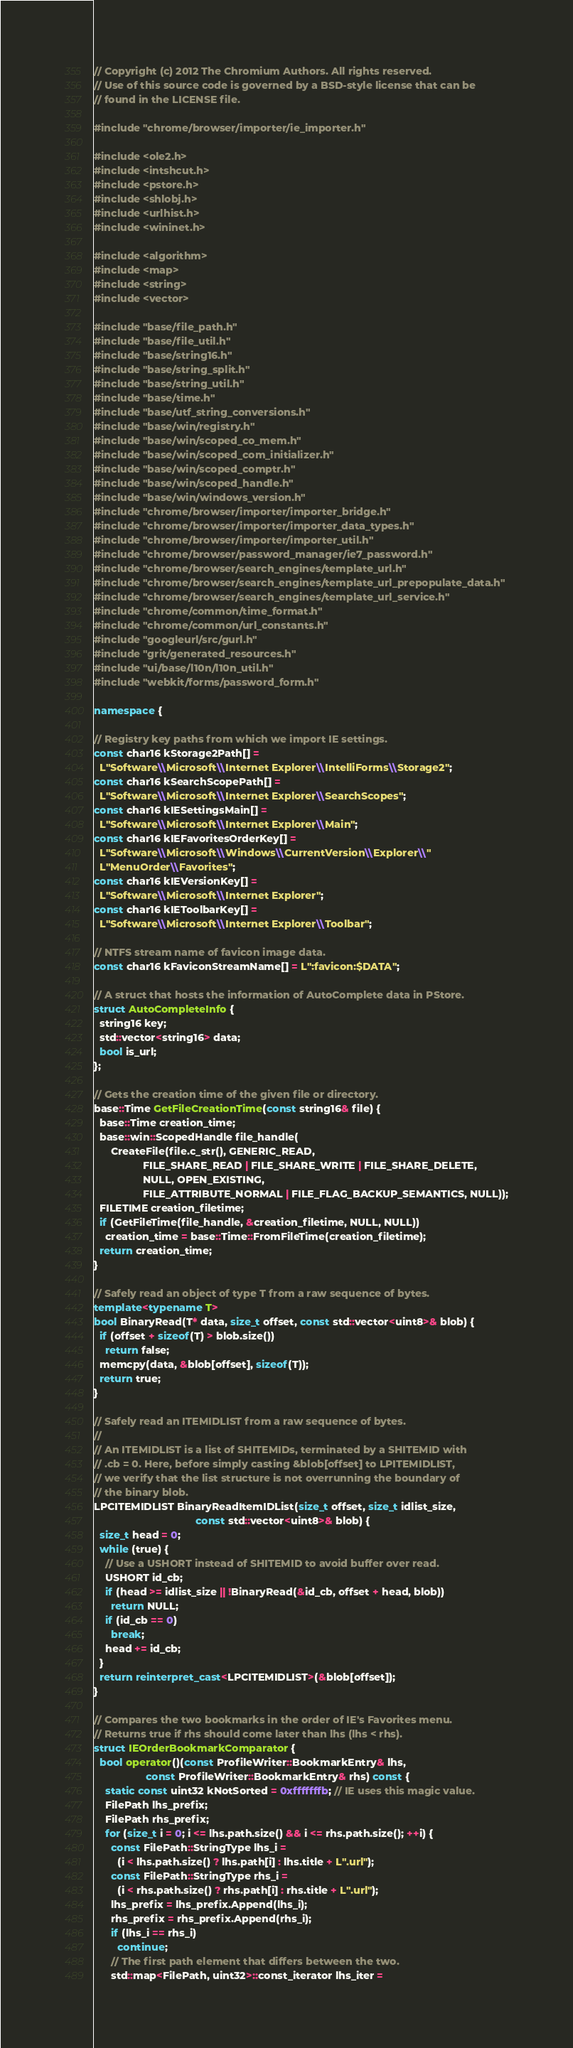Convert code to text. <code><loc_0><loc_0><loc_500><loc_500><_C++_>// Copyright (c) 2012 The Chromium Authors. All rights reserved.
// Use of this source code is governed by a BSD-style license that can be
// found in the LICENSE file.

#include "chrome/browser/importer/ie_importer.h"

#include <ole2.h>
#include <intshcut.h>
#include <pstore.h>
#include <shlobj.h>
#include <urlhist.h>
#include <wininet.h>

#include <algorithm>
#include <map>
#include <string>
#include <vector>

#include "base/file_path.h"
#include "base/file_util.h"
#include "base/string16.h"
#include "base/string_split.h"
#include "base/string_util.h"
#include "base/time.h"
#include "base/utf_string_conversions.h"
#include "base/win/registry.h"
#include "base/win/scoped_co_mem.h"
#include "base/win/scoped_com_initializer.h"
#include "base/win/scoped_comptr.h"
#include "base/win/scoped_handle.h"
#include "base/win/windows_version.h"
#include "chrome/browser/importer/importer_bridge.h"
#include "chrome/browser/importer/importer_data_types.h"
#include "chrome/browser/importer/importer_util.h"
#include "chrome/browser/password_manager/ie7_password.h"
#include "chrome/browser/search_engines/template_url.h"
#include "chrome/browser/search_engines/template_url_prepopulate_data.h"
#include "chrome/browser/search_engines/template_url_service.h"
#include "chrome/common/time_format.h"
#include "chrome/common/url_constants.h"
#include "googleurl/src/gurl.h"
#include "grit/generated_resources.h"
#include "ui/base/l10n/l10n_util.h"
#include "webkit/forms/password_form.h"

namespace {

// Registry key paths from which we import IE settings.
const char16 kStorage2Path[] =
  L"Software\\Microsoft\\Internet Explorer\\IntelliForms\\Storage2";
const char16 kSearchScopePath[] =
  L"Software\\Microsoft\\Internet Explorer\\SearchScopes";
const char16 kIESettingsMain[] =
  L"Software\\Microsoft\\Internet Explorer\\Main";
const char16 kIEFavoritesOrderKey[] =
  L"Software\\Microsoft\\Windows\\CurrentVersion\\Explorer\\"
  L"MenuOrder\\Favorites";
const char16 kIEVersionKey[] =
  L"Software\\Microsoft\\Internet Explorer";
const char16 kIEToolbarKey[] =
  L"Software\\Microsoft\\Internet Explorer\\Toolbar";

// NTFS stream name of favicon image data.
const char16 kFaviconStreamName[] = L":favicon:$DATA";

// A struct that hosts the information of AutoComplete data in PStore.
struct AutoCompleteInfo {
  string16 key;
  std::vector<string16> data;
  bool is_url;
};

// Gets the creation time of the given file or directory.
base::Time GetFileCreationTime(const string16& file) {
  base::Time creation_time;
  base::win::ScopedHandle file_handle(
      CreateFile(file.c_str(), GENERIC_READ,
                 FILE_SHARE_READ | FILE_SHARE_WRITE | FILE_SHARE_DELETE,
                 NULL, OPEN_EXISTING,
                 FILE_ATTRIBUTE_NORMAL | FILE_FLAG_BACKUP_SEMANTICS, NULL));
  FILETIME creation_filetime;
  if (GetFileTime(file_handle, &creation_filetime, NULL, NULL))
    creation_time = base::Time::FromFileTime(creation_filetime);
  return creation_time;
}

// Safely read an object of type T from a raw sequence of bytes.
template<typename T>
bool BinaryRead(T* data, size_t offset, const std::vector<uint8>& blob) {
  if (offset + sizeof(T) > blob.size())
    return false;
  memcpy(data, &blob[offset], sizeof(T));
  return true;
}

// Safely read an ITEMIDLIST from a raw sequence of bytes.
//
// An ITEMIDLIST is a list of SHITEMIDs, terminated by a SHITEMID with
// .cb = 0. Here, before simply casting &blob[offset] to LPITEMIDLIST,
// we verify that the list structure is not overrunning the boundary of
// the binary blob.
LPCITEMIDLIST BinaryReadItemIDList(size_t offset, size_t idlist_size,
                                   const std::vector<uint8>& blob) {
  size_t head = 0;
  while (true) {
    // Use a USHORT instead of SHITEMID to avoid buffer over read.
    USHORT id_cb;
    if (head >= idlist_size || !BinaryRead(&id_cb, offset + head, blob))
      return NULL;
    if (id_cb == 0)
      break;
    head += id_cb;
  }
  return reinterpret_cast<LPCITEMIDLIST>(&blob[offset]);
}

// Compares the two bookmarks in the order of IE's Favorites menu.
// Returns true if rhs should come later than lhs (lhs < rhs).
struct IEOrderBookmarkComparator {
  bool operator()(const ProfileWriter::BookmarkEntry& lhs,
                  const ProfileWriter::BookmarkEntry& rhs) const {
    static const uint32 kNotSorted = 0xfffffffb; // IE uses this magic value.
    FilePath lhs_prefix;
    FilePath rhs_prefix;
    for (size_t i = 0; i <= lhs.path.size() && i <= rhs.path.size(); ++i) {
      const FilePath::StringType lhs_i =
        (i < lhs.path.size() ? lhs.path[i] : lhs.title + L".url");
      const FilePath::StringType rhs_i =
        (i < rhs.path.size() ? rhs.path[i] : rhs.title + L".url");
      lhs_prefix = lhs_prefix.Append(lhs_i);
      rhs_prefix = rhs_prefix.Append(rhs_i);
      if (lhs_i == rhs_i)
        continue;
      // The first path element that differs between the two.
      std::map<FilePath, uint32>::const_iterator lhs_iter =</code> 